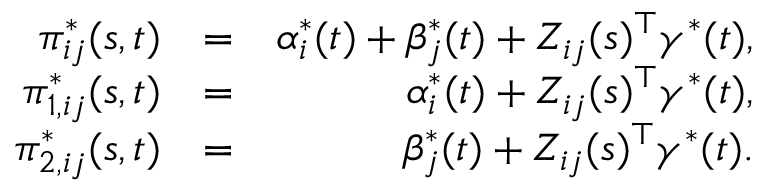<formula> <loc_0><loc_0><loc_500><loc_500>\begin{array} { r l r } { \pi _ { i j } ^ { * } ( s , t ) } & { = } & { \alpha _ { i } ^ { * } ( t ) + \beta _ { j } ^ { * } ( t ) + Z _ { i j } ( s ) ^ { \top } \gamma ^ { * } ( t ) , } \\ { \pi _ { 1 , i j } ^ { * } ( s , t ) } & { = } & { \alpha _ { i } ^ { * } ( t ) + Z _ { i j } ( s ) ^ { \top } \gamma ^ { * } ( t ) , } \\ { \pi _ { 2 , i j } ^ { * } ( s , t ) } & { = } & { \beta _ { j } ^ { * } ( t ) + Z _ { i j } ( s ) ^ { \top } \gamma ^ { * } ( t ) . } \end{array}</formula> 